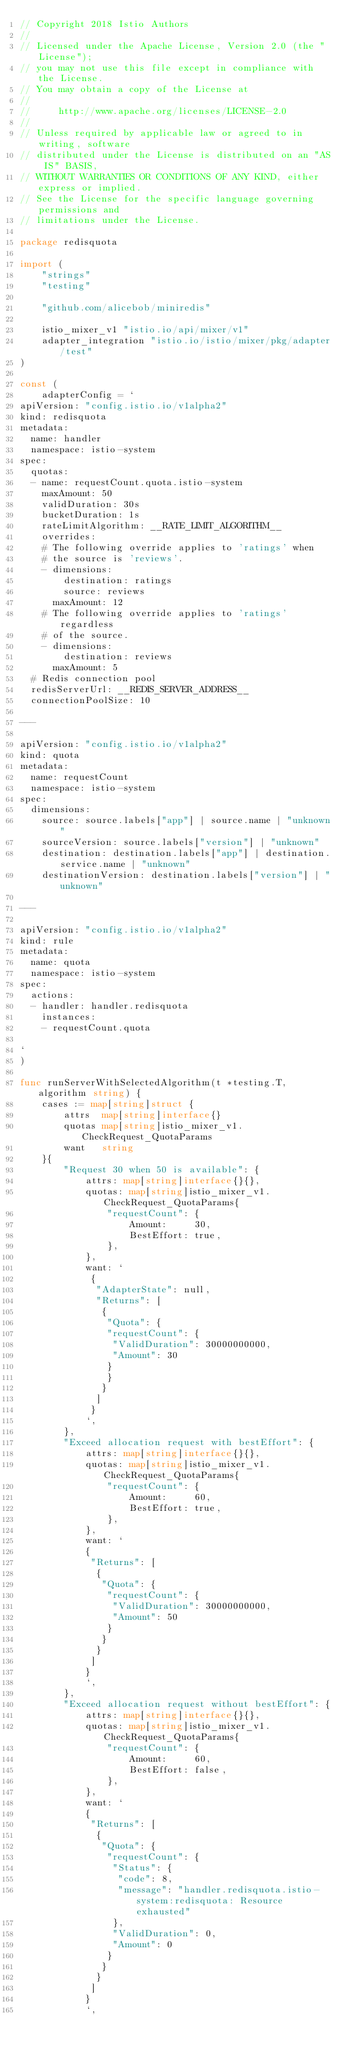<code> <loc_0><loc_0><loc_500><loc_500><_Go_>// Copyright 2018 Istio Authors
//
// Licensed under the Apache License, Version 2.0 (the "License");
// you may not use this file except in compliance with the License.
// You may obtain a copy of the License at
//
//     http://www.apache.org/licenses/LICENSE-2.0
//
// Unless required by applicable law or agreed to in writing, software
// distributed under the License is distributed on an "AS IS" BASIS,
// WITHOUT WARRANTIES OR CONDITIONS OF ANY KIND, either express or implied.
// See the License for the specific language governing permissions and
// limitations under the License.

package redisquota

import (
	"strings"
	"testing"

	"github.com/alicebob/miniredis"

	istio_mixer_v1 "istio.io/api/mixer/v1"
	adapter_integration "istio.io/istio/mixer/pkg/adapter/test"
)

const (
	adapterConfig = `
apiVersion: "config.istio.io/v1alpha2"
kind: redisquota
metadata:
  name: handler
  namespace: istio-system
spec:
  quotas:
  - name: requestCount.quota.istio-system
    maxAmount: 50
    validDuration: 30s
    bucketDuration: 1s
    rateLimitAlgorithm: __RATE_LIMIT_ALGORITHM__
    overrides:
    # The following override applies to 'ratings' when
    # the source is 'reviews'.
    - dimensions:
        destination: ratings
        source: reviews
      maxAmount: 12
    # The following override applies to 'ratings' regardless
    # of the source.
    - dimensions:
        destination: reviews
      maxAmount: 5
  # Redis connection pool
  redisServerUrl: __REDIS_SERVER_ADDRESS__
  connectionPoolSize: 10

---

apiVersion: "config.istio.io/v1alpha2"
kind: quota
metadata:
  name: requestCount
  namespace: istio-system
spec:
  dimensions:
    source: source.labels["app"] | source.name | "unknown"
    sourceVersion: source.labels["version"] | "unknown"
    destination: destination.labels["app"] | destination.service.name | "unknown"
    destinationVersion: destination.labels["version"] | "unknown"

---

apiVersion: "config.istio.io/v1alpha2"
kind: rule
metadata:
  name: quota
  namespace: istio-system
spec:
  actions:
  - handler: handler.redisquota
    instances:
    - requestCount.quota

`
)

func runServerWithSelectedAlgorithm(t *testing.T, algorithm string) {
	cases := map[string]struct {
		attrs  map[string]interface{}
		quotas map[string]istio_mixer_v1.CheckRequest_QuotaParams
		want   string
	}{
		"Request 30 when 50 is available": {
			attrs: map[string]interface{}{},
			quotas: map[string]istio_mixer_v1.CheckRequest_QuotaParams{
				"requestCount": {
					Amount:     30,
					BestEffort: true,
				},
			},
			want: `
			 {
			  "AdapterState": null,
			  "Returns": [
			   {
			    "Quota": {
			 	"requestCount": {
			 	 "ValidDuration": 30000000000,
			 	 "Amount": 30
			 	}
			    }
			   }
			  ]
			 }
			`,
		},
		"Exceed allocation request with bestEffort": {
			attrs: map[string]interface{}{},
			quotas: map[string]istio_mixer_v1.CheckRequest_QuotaParams{
				"requestCount": {
					Amount:     60,
					BestEffort: true,
				},
			},
			want: `
			{
			 "Returns": [
			  {
			   "Quota": {
				"requestCount": {
				 "ValidDuration": 30000000000,
				 "Amount": 50
				}
			   }
			  }
			 ]
			}
			`,
		},
		"Exceed allocation request without bestEffort": {
			attrs: map[string]interface{}{},
			quotas: map[string]istio_mixer_v1.CheckRequest_QuotaParams{
				"requestCount": {
					Amount:     60,
					BestEffort: false,
				},
			},
			want: `
			{
			 "Returns": [
			  {
			   "Quota": {
			    "requestCount": {
                 "Status": {
                  "code": 8,
                  "message": "handler.redisquota.istio-system:redisquota: Resource exhausted"
                 },
			     "ValidDuration": 0,
			     "Amount": 0
			    }
			   }
			  }
			 ]
			}
			`,</code> 